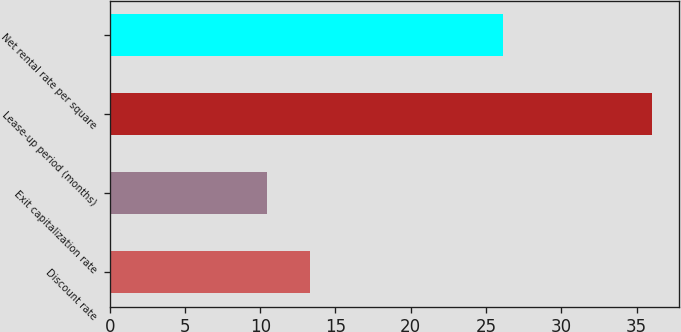Convert chart. <chart><loc_0><loc_0><loc_500><loc_500><bar_chart><fcel>Discount rate<fcel>Exit capitalization rate<fcel>Lease-up period (months)<fcel>Net rental rate per square<nl><fcel>13.3<fcel>10.46<fcel>36<fcel>26.14<nl></chart> 